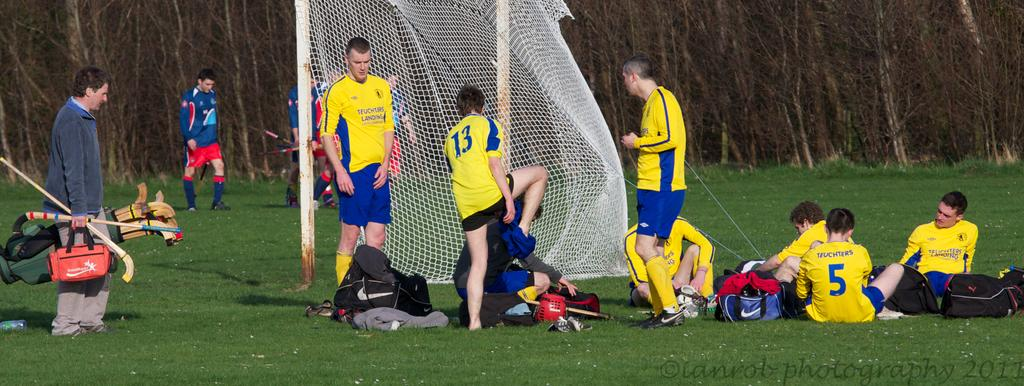Provide a one-sentence caption for the provided image. field hockey players resting on a field in blue and yellow jerseys with numbers such as 5 and 13. 